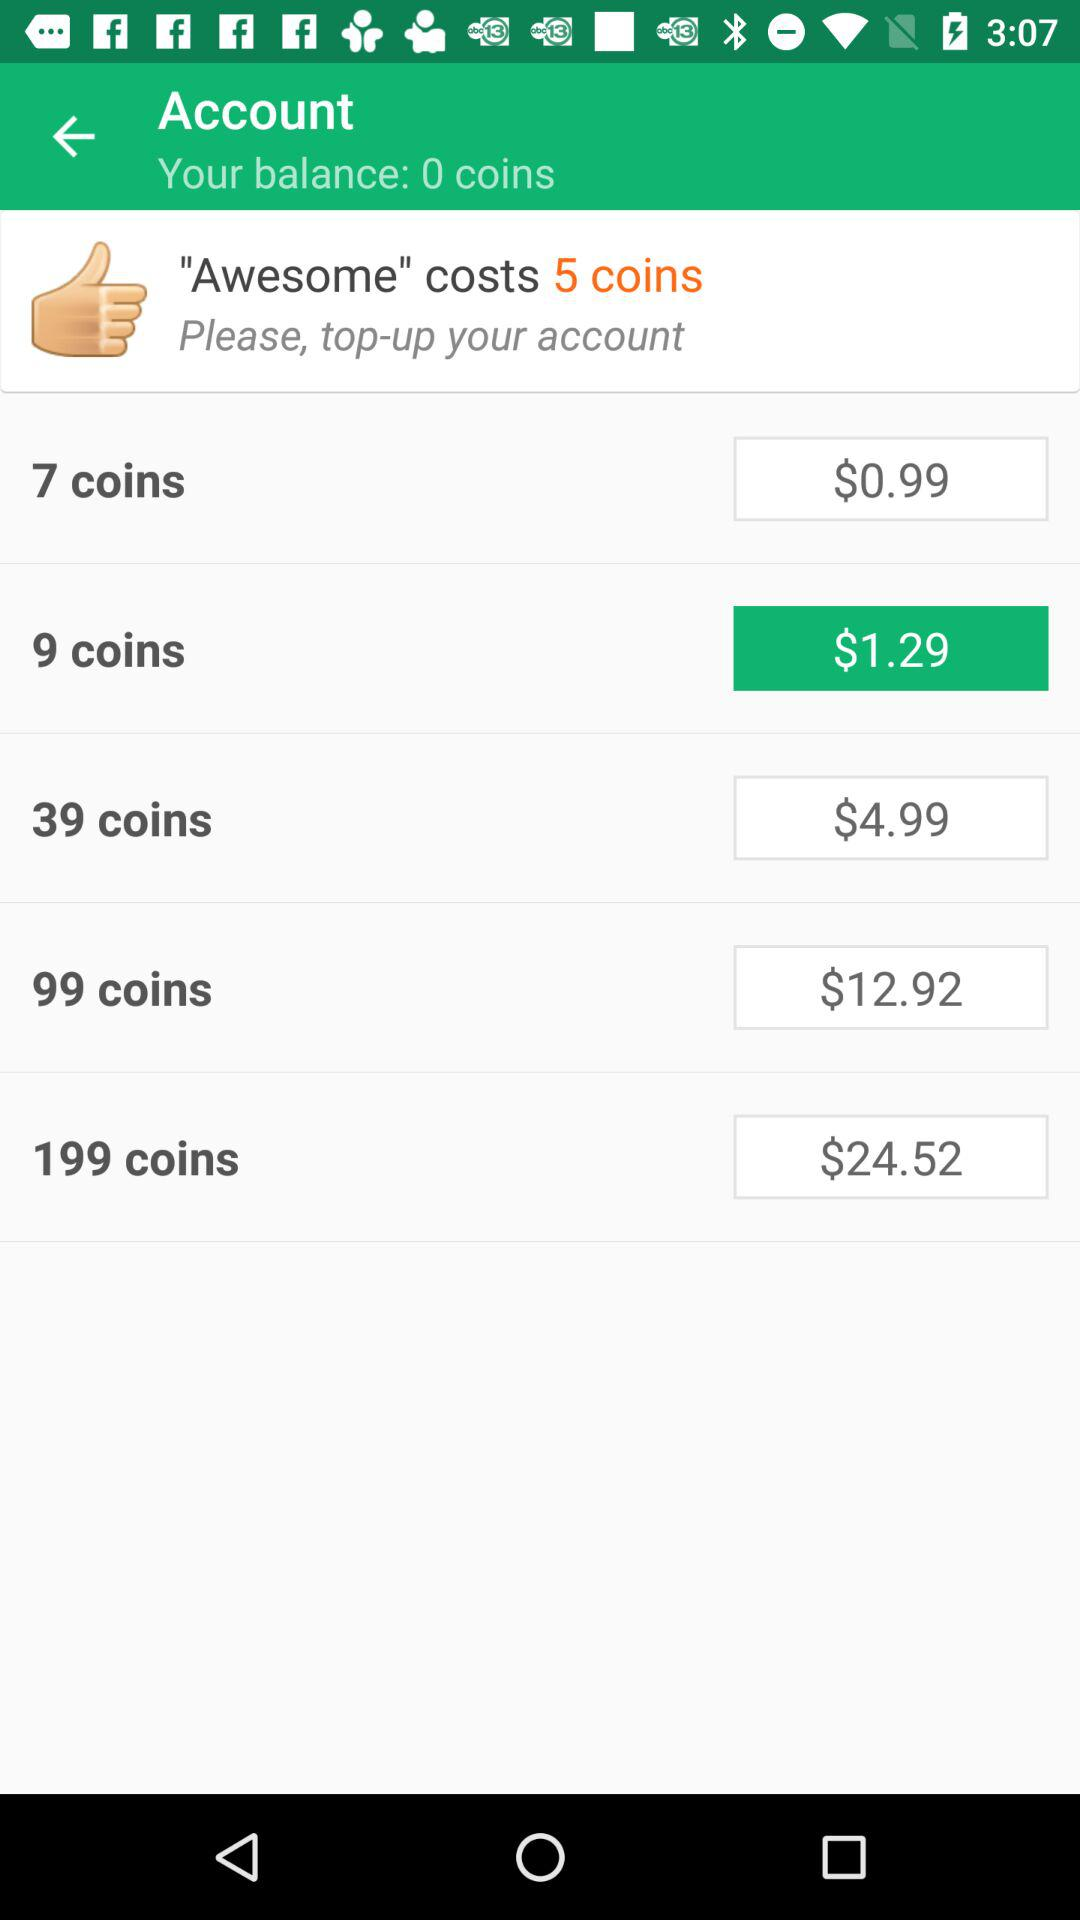What review costs 5 coins? The review "Awesome" costs 5 coins. 